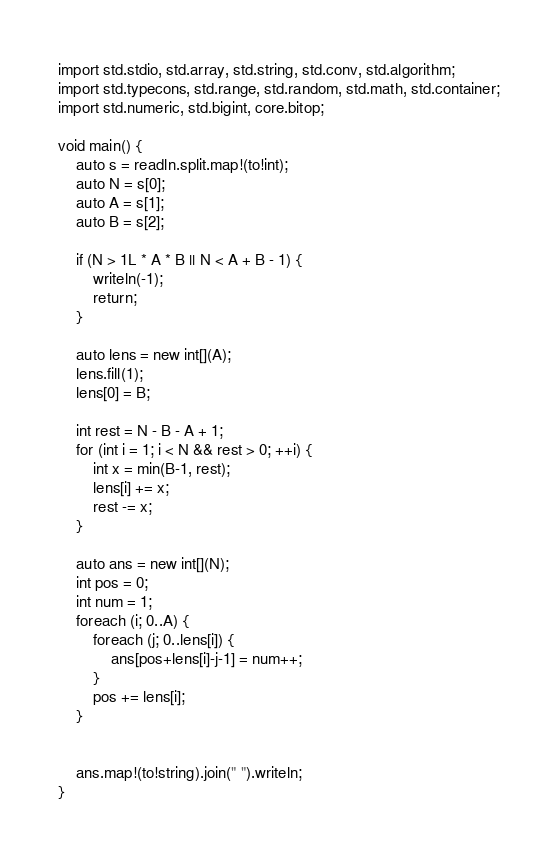<code> <loc_0><loc_0><loc_500><loc_500><_D_>import std.stdio, std.array, std.string, std.conv, std.algorithm;
import std.typecons, std.range, std.random, std.math, std.container;
import std.numeric, std.bigint, core.bitop;

void main() {
    auto s = readln.split.map!(to!int);
    auto N = s[0];
    auto A = s[1];
    auto B = s[2];

    if (N > 1L * A * B || N < A + B - 1) {
        writeln(-1);
        return;
    }

    auto lens = new int[](A);
    lens.fill(1);
    lens[0] = B;

    int rest = N - B - A + 1;
    for (int i = 1; i < N && rest > 0; ++i) {
        int x = min(B-1, rest);
        lens[i] += x;
        rest -= x;
    }

    auto ans = new int[](N);
    int pos = 0;
    int num = 1;
    foreach (i; 0..A) {
        foreach (j; 0..lens[i]) {
            ans[pos+lens[i]-j-1] = num++;
        }
        pos += lens[i];
    }

    
    ans.map!(to!string).join(" ").writeln;
}
</code> 